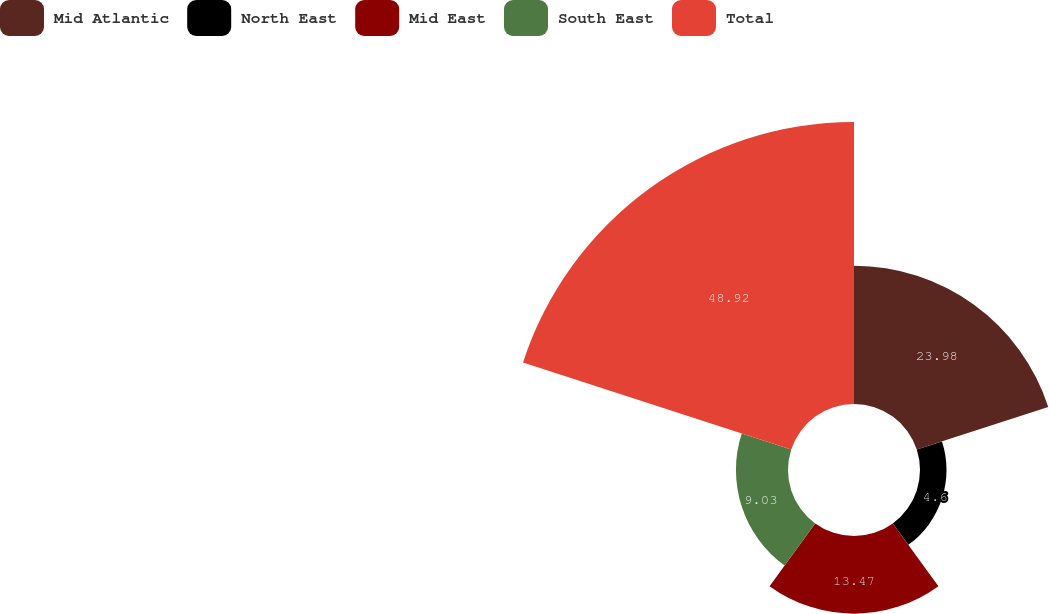Convert chart to OTSL. <chart><loc_0><loc_0><loc_500><loc_500><pie_chart><fcel>Mid Atlantic<fcel>North East<fcel>Mid East<fcel>South East<fcel>Total<nl><fcel>23.98%<fcel>4.6%<fcel>13.47%<fcel>9.03%<fcel>48.92%<nl></chart> 